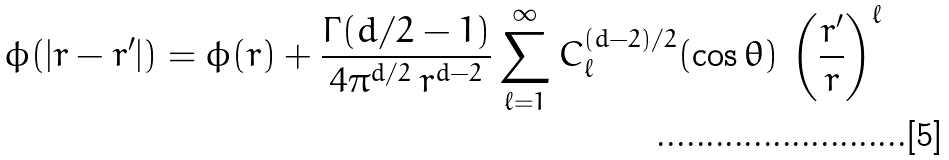<formula> <loc_0><loc_0><loc_500><loc_500>\phi ( | { r } - { r } ^ { \prime } | ) = \phi ( r ) + \frac { \Gamma ( d / 2 - 1 ) } { 4 \pi ^ { d / 2 } \, r ^ { d - 2 } } \sum _ { \ell = 1 } ^ { \infty } C _ { \ell } ^ { ( d - 2 ) / 2 } ( \cos \theta ) \, \left ( \frac { r ^ { \prime } } { r } \right ) ^ { \ell }</formula> 